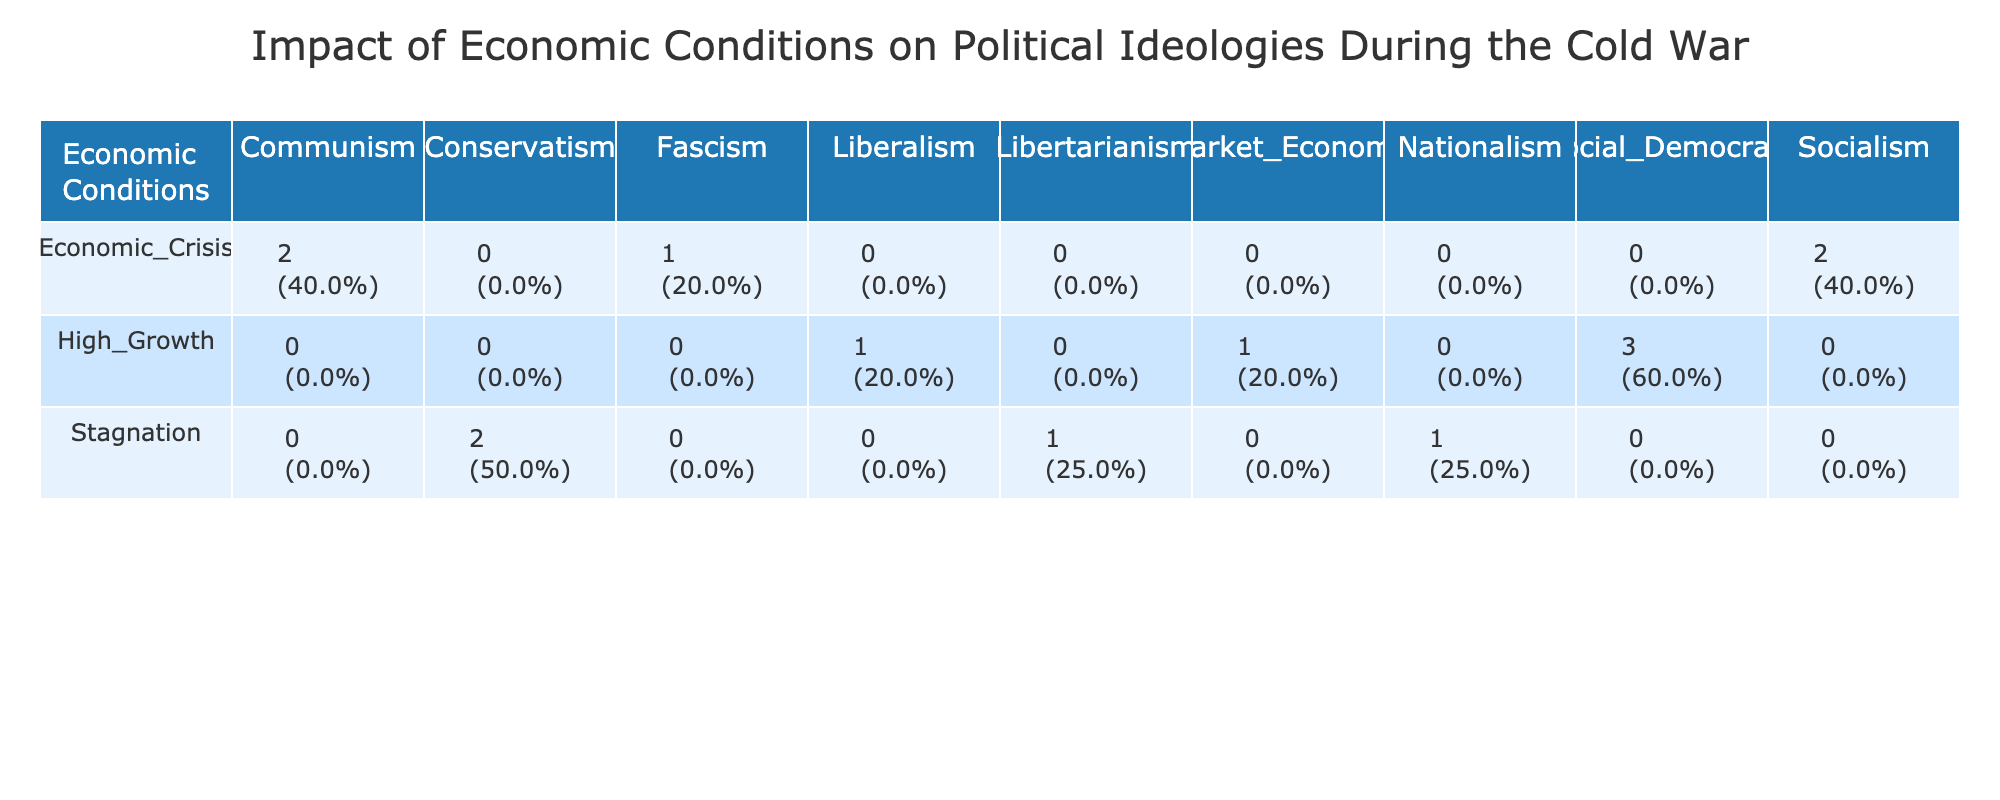What political ideology was associated with high growth in Sweden? According to the table, Sweden had Social Democracy listed under the High Growth economic condition, indicating this political ideology was prevalent during that time.
Answer: Social Democracy Which economic condition is linked to Fascism in Spain? The table shows that the economic condition associated with Fascism in Spain is Economic Crisis, as per the entry for the year 1945.
Answer: Economic Crisis What is the total number of political ideologies listed for the Economic Crisis condition? Upon examining the Economic Crisis row, the table indicates four distinct political ideologies: Communism, Socialism, and Fascism. The total is 3 unique ideologies.
Answer: 3 Is Socialism associated with stagnation in any country during the Cold War? In the table, there are no entries for Socialism under the Stagnation economic condition, which indicates Socialism is not connected to stagnation during this period.
Answer: No What is the proportion of Political Ideology categorized as Conservatism in relation to Economic Conditions? There are two occurrences of Conservatism associated with Stagnation (United States and United Kingdom), out of a total of 7 occurrences of ideologies under Economic Conditions. Therefore, its proportion is 2 out of 7, or approximately 28.57%.
Answer: 28.57% How many political ideologies were found during high growth and stagnation combined? By checking the High Growth and Stagnation rows, we find a total of 5 unique ideologies under High Growth (Social Democracy, Liberalism, Market Economy) and 4 under Stagnation (Conservatism, Libertarianism, Nationalism). Adding these gives us 5 + 3 = 8 unique ideologies combined.
Answer: 8 Which ideology appears with a frequency of one under Economic Crisis? In the table, Fascism is the only ideology listed once in the Economic Crisis row, making it a unique occurrence.
Answer: Fascism What ideological pattern emerges when comparing Economic Conditions and their associated ideologies over time? By analyzing the data, it's seen that Economic Conditions like High Growth predominantly lead to progressive ideologies (Social Democracy, Liberalism), while Economic Crisis tends to lead towards more extreme ideologies (Communism, Fascism) as indicated by multiple geographic examples and years.
Answer: Progressive and Extreme ideologies How does Stagnation relate to the types of ideologies observed? The Stagnation condition in the table shows a mix of ideologies including Conservatism, Libertarianism, and Nationalism, suggesting a tendency towards traditional or reactionary political movements during periods of economic stagnation.
Answer: Traditional/Reactionary ideologies 